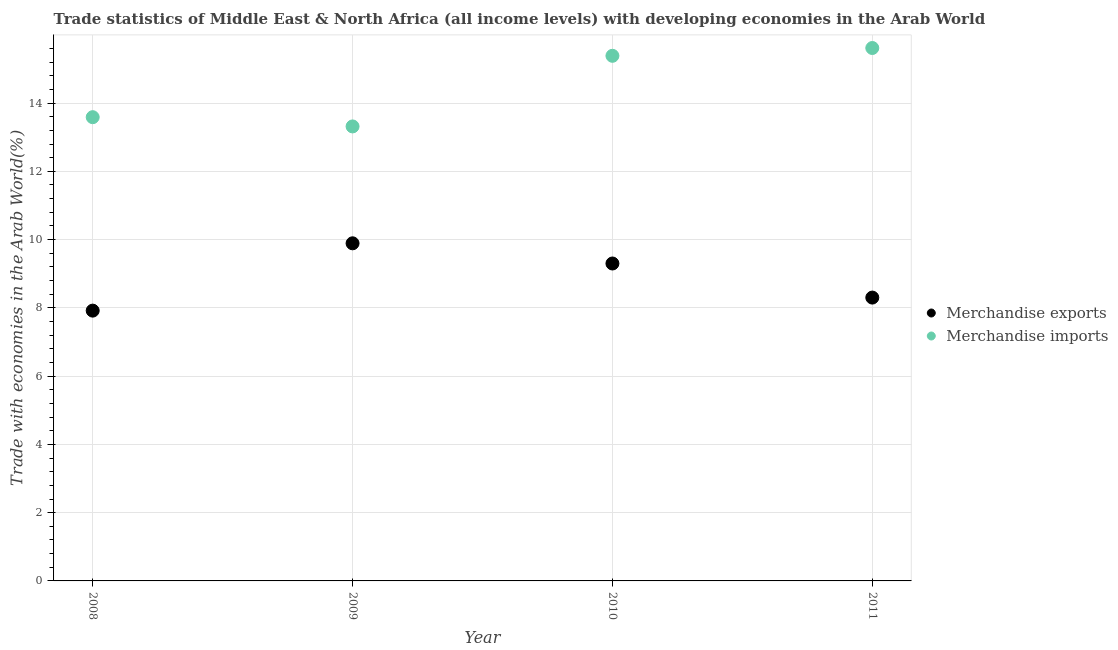What is the merchandise exports in 2009?
Provide a succinct answer. 9.89. Across all years, what is the maximum merchandise exports?
Provide a succinct answer. 9.89. Across all years, what is the minimum merchandise exports?
Make the answer very short. 7.92. In which year was the merchandise exports minimum?
Keep it short and to the point. 2008. What is the total merchandise imports in the graph?
Offer a very short reply. 57.9. What is the difference between the merchandise exports in 2008 and that in 2011?
Provide a succinct answer. -0.38. What is the difference between the merchandise imports in 2011 and the merchandise exports in 2008?
Ensure brevity in your answer.  7.69. What is the average merchandise imports per year?
Provide a short and direct response. 14.48. In the year 2011, what is the difference between the merchandise exports and merchandise imports?
Your answer should be very brief. -7.31. What is the ratio of the merchandise exports in 2009 to that in 2010?
Ensure brevity in your answer.  1.06. What is the difference between the highest and the second highest merchandise imports?
Provide a short and direct response. 0.23. What is the difference between the highest and the lowest merchandise imports?
Give a very brief answer. 2.3. In how many years, is the merchandise imports greater than the average merchandise imports taken over all years?
Keep it short and to the point. 2. Is the merchandise imports strictly less than the merchandise exports over the years?
Offer a terse response. No. How many dotlines are there?
Keep it short and to the point. 2. How many years are there in the graph?
Keep it short and to the point. 4. What is the difference between two consecutive major ticks on the Y-axis?
Provide a succinct answer. 2. Are the values on the major ticks of Y-axis written in scientific E-notation?
Your answer should be compact. No. Does the graph contain any zero values?
Offer a very short reply. No. Does the graph contain grids?
Your answer should be very brief. Yes. Where does the legend appear in the graph?
Your response must be concise. Center right. How many legend labels are there?
Provide a short and direct response. 2. How are the legend labels stacked?
Your answer should be compact. Vertical. What is the title of the graph?
Your response must be concise. Trade statistics of Middle East & North Africa (all income levels) with developing economies in the Arab World. Does "Taxes on profits and capital gains" appear as one of the legend labels in the graph?
Ensure brevity in your answer.  No. What is the label or title of the Y-axis?
Make the answer very short. Trade with economies in the Arab World(%). What is the Trade with economies in the Arab World(%) in Merchandise exports in 2008?
Your response must be concise. 7.92. What is the Trade with economies in the Arab World(%) in Merchandise imports in 2008?
Your response must be concise. 13.59. What is the Trade with economies in the Arab World(%) of Merchandise exports in 2009?
Your answer should be compact. 9.89. What is the Trade with economies in the Arab World(%) of Merchandise imports in 2009?
Ensure brevity in your answer.  13.32. What is the Trade with economies in the Arab World(%) of Merchandise exports in 2010?
Provide a succinct answer. 9.3. What is the Trade with economies in the Arab World(%) in Merchandise imports in 2010?
Your answer should be compact. 15.38. What is the Trade with economies in the Arab World(%) in Merchandise exports in 2011?
Your response must be concise. 8.3. What is the Trade with economies in the Arab World(%) of Merchandise imports in 2011?
Provide a succinct answer. 15.61. Across all years, what is the maximum Trade with economies in the Arab World(%) of Merchandise exports?
Your response must be concise. 9.89. Across all years, what is the maximum Trade with economies in the Arab World(%) in Merchandise imports?
Offer a terse response. 15.61. Across all years, what is the minimum Trade with economies in the Arab World(%) in Merchandise exports?
Keep it short and to the point. 7.92. Across all years, what is the minimum Trade with economies in the Arab World(%) of Merchandise imports?
Ensure brevity in your answer.  13.32. What is the total Trade with economies in the Arab World(%) of Merchandise exports in the graph?
Your response must be concise. 35.41. What is the total Trade with economies in the Arab World(%) of Merchandise imports in the graph?
Offer a terse response. 57.9. What is the difference between the Trade with economies in the Arab World(%) in Merchandise exports in 2008 and that in 2009?
Keep it short and to the point. -1.97. What is the difference between the Trade with economies in the Arab World(%) in Merchandise imports in 2008 and that in 2009?
Provide a succinct answer. 0.27. What is the difference between the Trade with economies in the Arab World(%) in Merchandise exports in 2008 and that in 2010?
Provide a short and direct response. -1.38. What is the difference between the Trade with economies in the Arab World(%) in Merchandise imports in 2008 and that in 2010?
Give a very brief answer. -1.8. What is the difference between the Trade with economies in the Arab World(%) in Merchandise exports in 2008 and that in 2011?
Your response must be concise. -0.38. What is the difference between the Trade with economies in the Arab World(%) in Merchandise imports in 2008 and that in 2011?
Keep it short and to the point. -2.03. What is the difference between the Trade with economies in the Arab World(%) of Merchandise exports in 2009 and that in 2010?
Provide a succinct answer. 0.59. What is the difference between the Trade with economies in the Arab World(%) of Merchandise imports in 2009 and that in 2010?
Provide a succinct answer. -2.07. What is the difference between the Trade with economies in the Arab World(%) of Merchandise exports in 2009 and that in 2011?
Offer a terse response. 1.59. What is the difference between the Trade with economies in the Arab World(%) in Merchandise imports in 2009 and that in 2011?
Provide a short and direct response. -2.3. What is the difference between the Trade with economies in the Arab World(%) in Merchandise exports in 2010 and that in 2011?
Offer a terse response. 1. What is the difference between the Trade with economies in the Arab World(%) of Merchandise imports in 2010 and that in 2011?
Offer a terse response. -0.23. What is the difference between the Trade with economies in the Arab World(%) in Merchandise exports in 2008 and the Trade with economies in the Arab World(%) in Merchandise imports in 2009?
Make the answer very short. -5.4. What is the difference between the Trade with economies in the Arab World(%) of Merchandise exports in 2008 and the Trade with economies in the Arab World(%) of Merchandise imports in 2010?
Ensure brevity in your answer.  -7.47. What is the difference between the Trade with economies in the Arab World(%) of Merchandise exports in 2008 and the Trade with economies in the Arab World(%) of Merchandise imports in 2011?
Ensure brevity in your answer.  -7.69. What is the difference between the Trade with economies in the Arab World(%) of Merchandise exports in 2009 and the Trade with economies in the Arab World(%) of Merchandise imports in 2010?
Make the answer very short. -5.49. What is the difference between the Trade with economies in the Arab World(%) of Merchandise exports in 2009 and the Trade with economies in the Arab World(%) of Merchandise imports in 2011?
Your response must be concise. -5.72. What is the difference between the Trade with economies in the Arab World(%) in Merchandise exports in 2010 and the Trade with economies in the Arab World(%) in Merchandise imports in 2011?
Keep it short and to the point. -6.31. What is the average Trade with economies in the Arab World(%) of Merchandise exports per year?
Provide a succinct answer. 8.85. What is the average Trade with economies in the Arab World(%) in Merchandise imports per year?
Give a very brief answer. 14.48. In the year 2008, what is the difference between the Trade with economies in the Arab World(%) of Merchandise exports and Trade with economies in the Arab World(%) of Merchandise imports?
Offer a very short reply. -5.67. In the year 2009, what is the difference between the Trade with economies in the Arab World(%) of Merchandise exports and Trade with economies in the Arab World(%) of Merchandise imports?
Give a very brief answer. -3.42. In the year 2010, what is the difference between the Trade with economies in the Arab World(%) in Merchandise exports and Trade with economies in the Arab World(%) in Merchandise imports?
Make the answer very short. -6.08. In the year 2011, what is the difference between the Trade with economies in the Arab World(%) of Merchandise exports and Trade with economies in the Arab World(%) of Merchandise imports?
Offer a very short reply. -7.31. What is the ratio of the Trade with economies in the Arab World(%) of Merchandise exports in 2008 to that in 2009?
Provide a short and direct response. 0.8. What is the ratio of the Trade with economies in the Arab World(%) of Merchandise imports in 2008 to that in 2009?
Provide a succinct answer. 1.02. What is the ratio of the Trade with economies in the Arab World(%) of Merchandise exports in 2008 to that in 2010?
Your response must be concise. 0.85. What is the ratio of the Trade with economies in the Arab World(%) in Merchandise imports in 2008 to that in 2010?
Your response must be concise. 0.88. What is the ratio of the Trade with economies in the Arab World(%) in Merchandise exports in 2008 to that in 2011?
Offer a terse response. 0.95. What is the ratio of the Trade with economies in the Arab World(%) of Merchandise imports in 2008 to that in 2011?
Provide a short and direct response. 0.87. What is the ratio of the Trade with economies in the Arab World(%) of Merchandise exports in 2009 to that in 2010?
Give a very brief answer. 1.06. What is the ratio of the Trade with economies in the Arab World(%) in Merchandise imports in 2009 to that in 2010?
Make the answer very short. 0.87. What is the ratio of the Trade with economies in the Arab World(%) of Merchandise exports in 2009 to that in 2011?
Your response must be concise. 1.19. What is the ratio of the Trade with economies in the Arab World(%) of Merchandise imports in 2009 to that in 2011?
Offer a very short reply. 0.85. What is the ratio of the Trade with economies in the Arab World(%) in Merchandise exports in 2010 to that in 2011?
Keep it short and to the point. 1.12. What is the ratio of the Trade with economies in the Arab World(%) of Merchandise imports in 2010 to that in 2011?
Give a very brief answer. 0.99. What is the difference between the highest and the second highest Trade with economies in the Arab World(%) in Merchandise exports?
Your answer should be very brief. 0.59. What is the difference between the highest and the second highest Trade with economies in the Arab World(%) in Merchandise imports?
Provide a succinct answer. 0.23. What is the difference between the highest and the lowest Trade with economies in the Arab World(%) in Merchandise exports?
Provide a short and direct response. 1.97. What is the difference between the highest and the lowest Trade with economies in the Arab World(%) of Merchandise imports?
Make the answer very short. 2.3. 